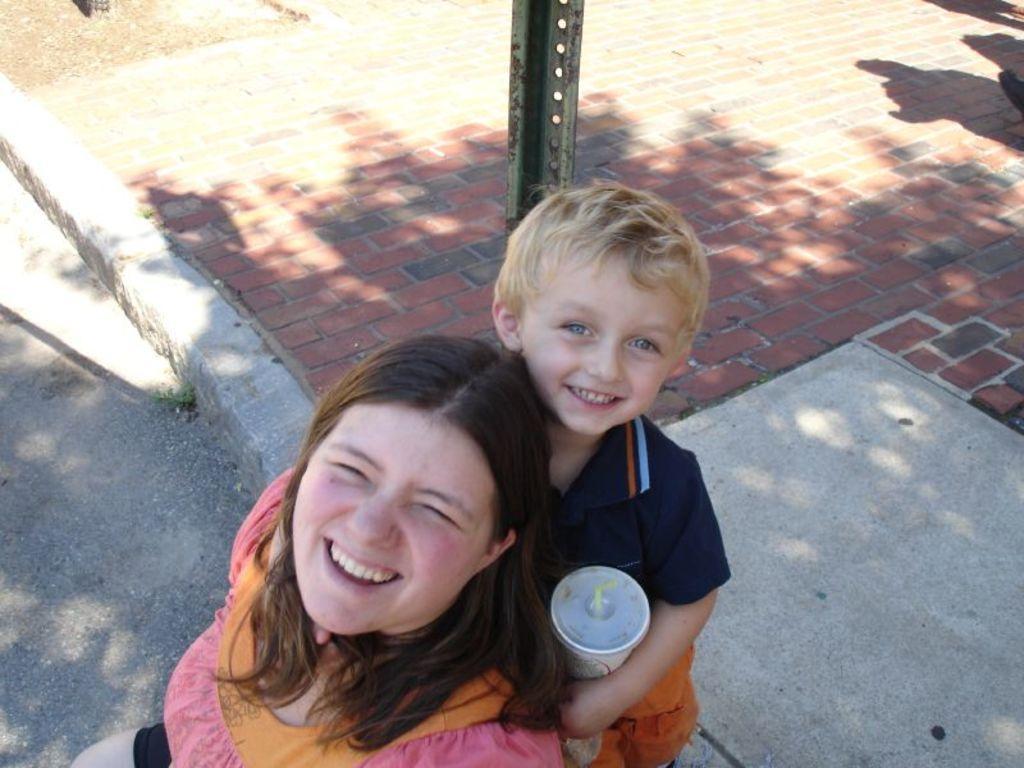How would you summarize this image in a sentence or two? In this image at the bottom there is one woman and one boy, and a boy is holding a glass. And in the background there is pole, in the center of the image there is pavement and road. 